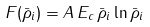<formula> <loc_0><loc_0><loc_500><loc_500>F ( \bar { \rho } _ { i } ) = A \, E _ { c } \, \bar { \rho } _ { i } \ln \bar { \rho } _ { i }</formula> 